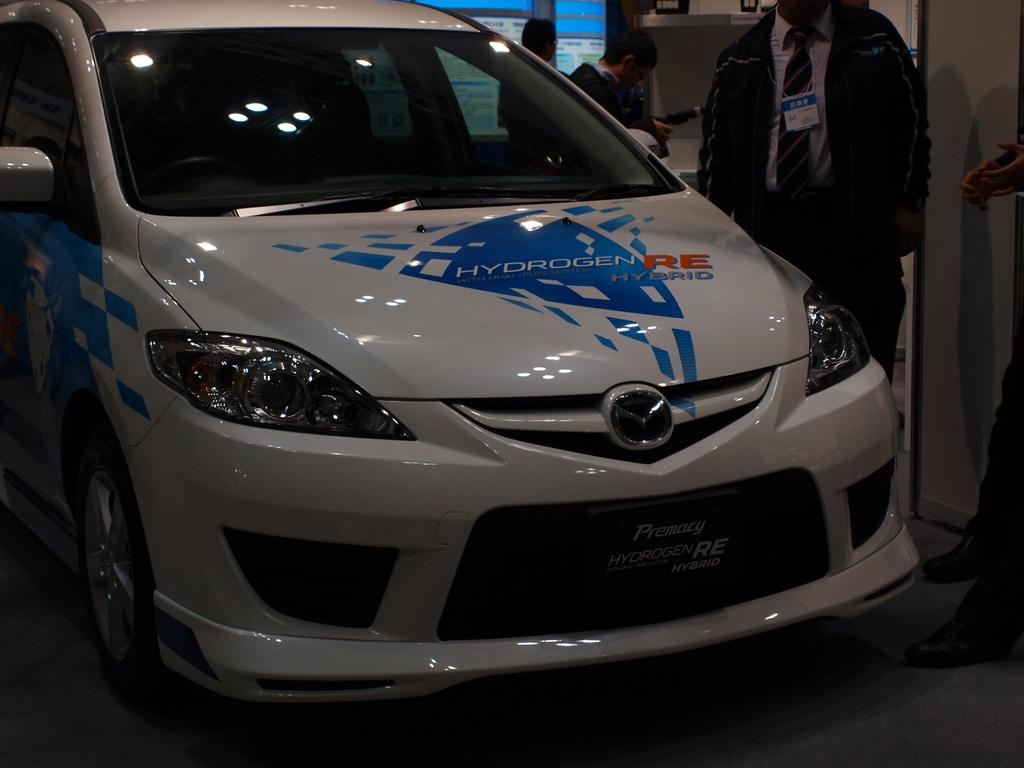What is the main subject in the image? There is a vehicle in the image. Can you describe the people in the image? There are people in the image. What can be seen beneath the vehicle and people? The ground is visible in the image. What is present in the background of the image? There is a wall in the image. What is on the shelf in the image? There is a shelf with objects in the image. What is written on the boards in the image? There are boards with text in the image. What type of ghost can be seen interacting with the vehicle in the image? There is no ghost present in the image; it features a vehicle, people, the ground, a wall, a shelf with objects, and boards with text. What sound does the marble make when it rolls on the ground in the image? There is no marble present in the image, so it cannot be determined what sound it would make if it were there. 